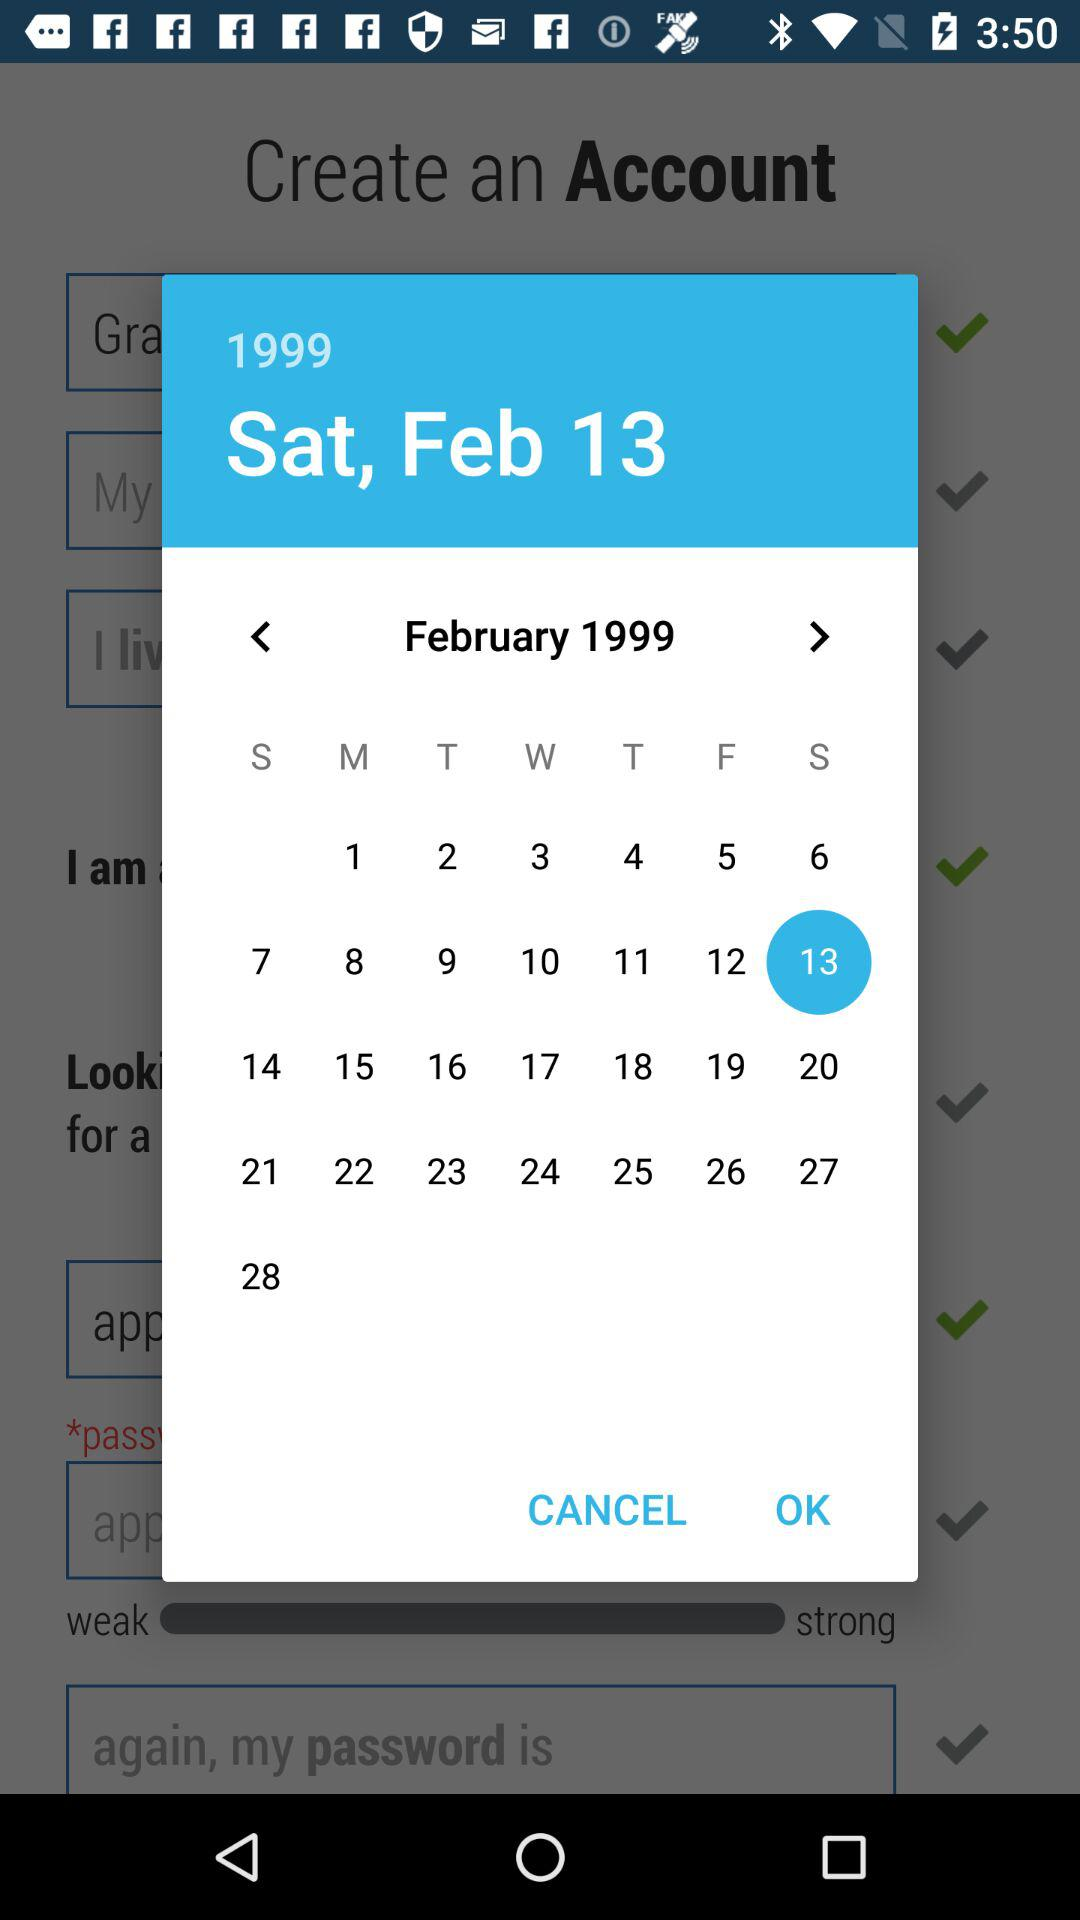Which date is selected? The selected date is Saturday, February 13, 1999. 